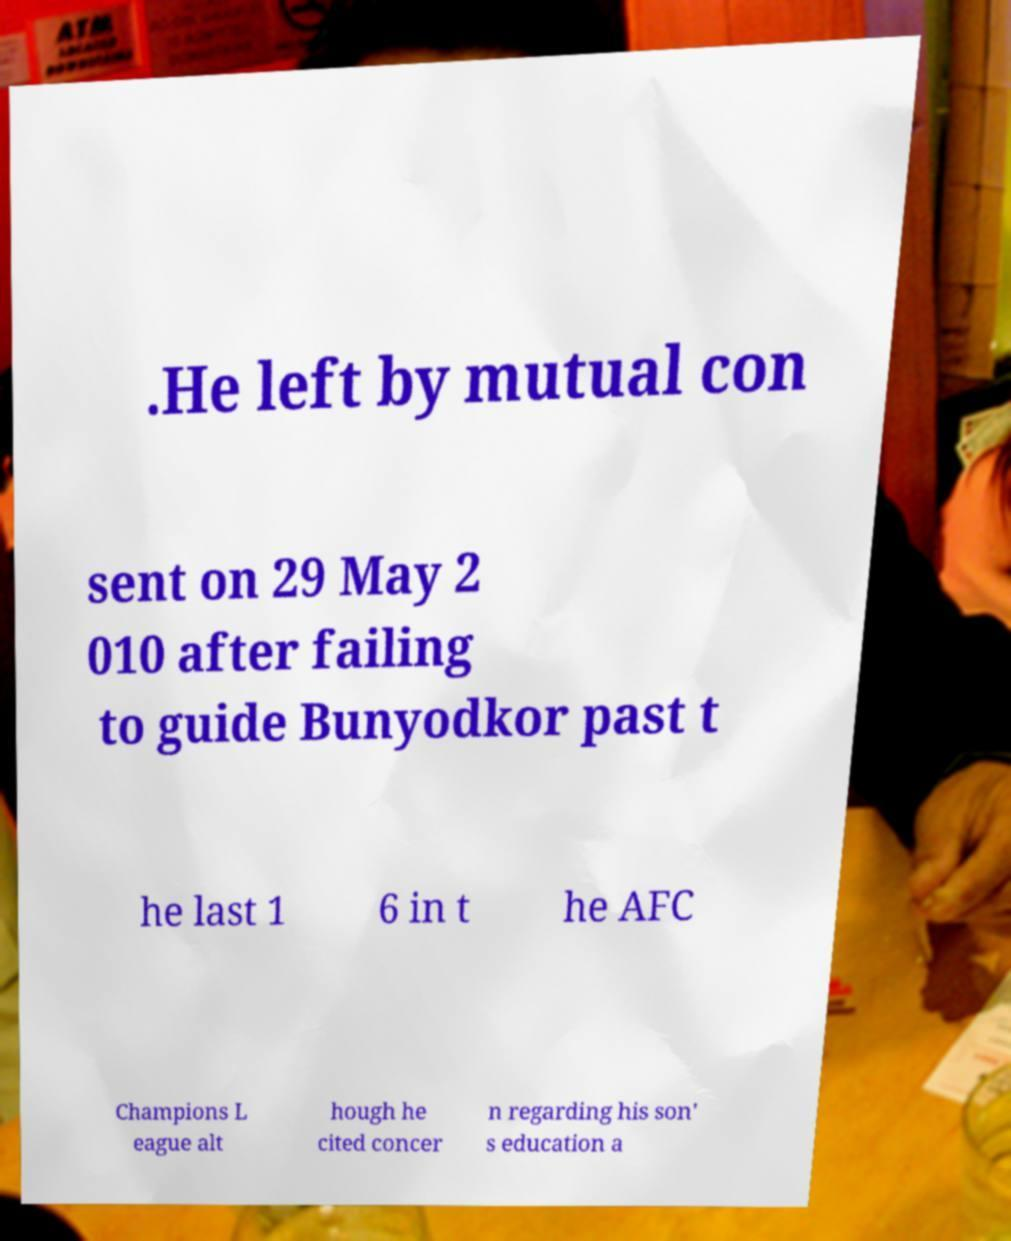There's text embedded in this image that I need extracted. Can you transcribe it verbatim? .He left by mutual con sent on 29 May 2 010 after failing to guide Bunyodkor past t he last 1 6 in t he AFC Champions L eague alt hough he cited concer n regarding his son' s education a 